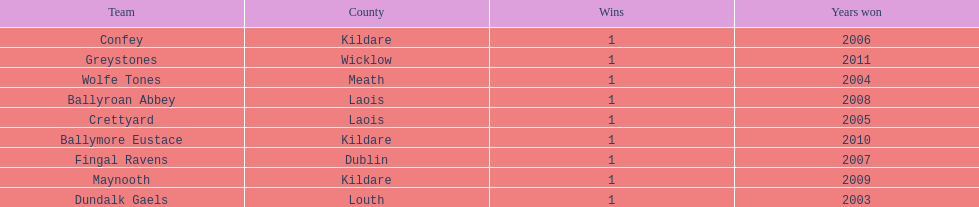Which county had the most number of wins? Kildare. 